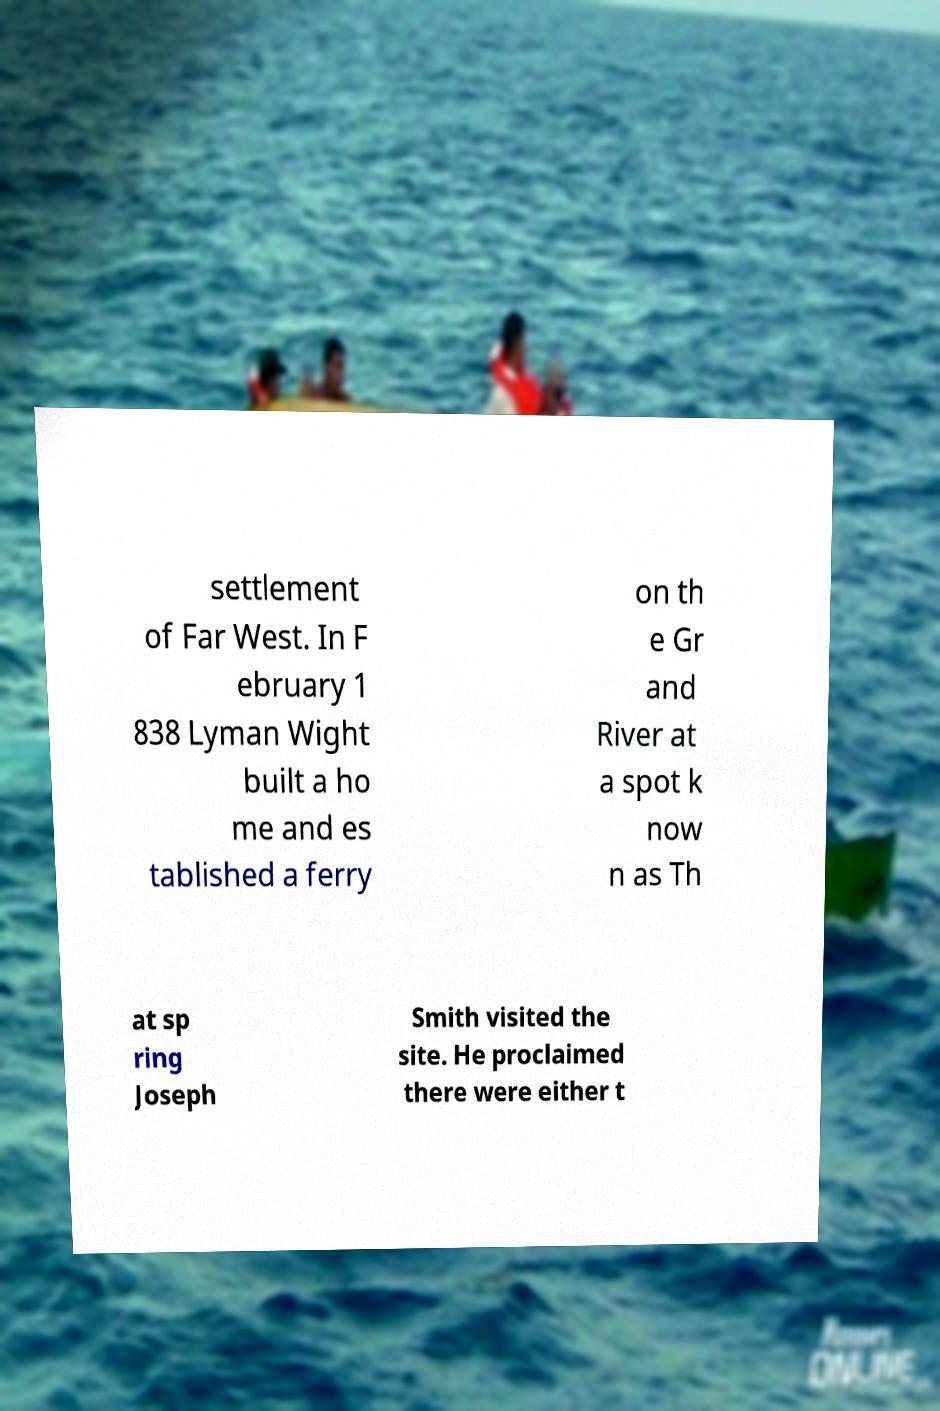There's text embedded in this image that I need extracted. Can you transcribe it verbatim? settlement of Far West. In F ebruary 1 838 Lyman Wight built a ho me and es tablished a ferry on th e Gr and River at a spot k now n as Th at sp ring Joseph Smith visited the site. He proclaimed there were either t 